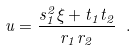<formula> <loc_0><loc_0><loc_500><loc_500>u = \frac { s _ { 1 } ^ { 2 } \xi + t _ { 1 } t _ { 2 } } { r _ { 1 } r _ { 2 } } \ .</formula> 